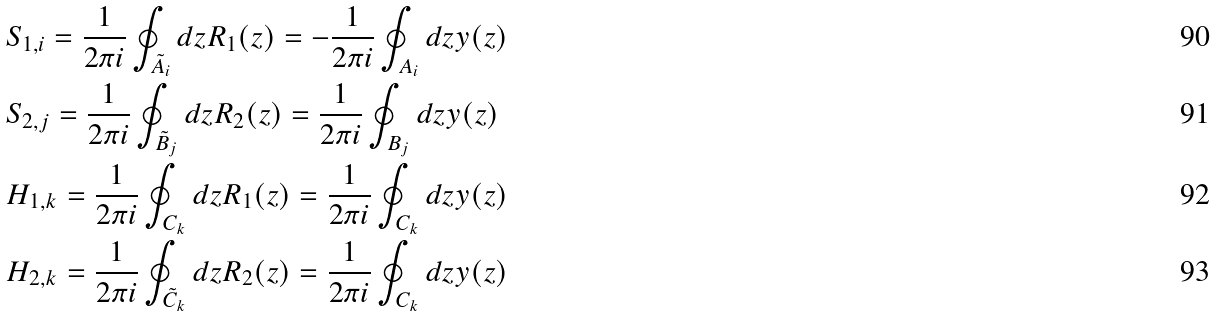<formula> <loc_0><loc_0><loc_500><loc_500>& S _ { 1 , i } = \frac { 1 } { 2 \pi i } \oint _ { \tilde { A } _ { i } } d z R _ { 1 } ( z ) = - \frac { 1 } { 2 \pi i } \oint _ { A _ { i } } d z y ( z ) \\ & S _ { 2 , j } = \frac { 1 } { 2 \pi i } \oint _ { \tilde { B } _ { j } } d z R _ { 2 } ( z ) = \frac { 1 } { 2 \pi i } \oint _ { B _ { j } } d z y ( z ) \\ & H _ { 1 , k } = \frac { 1 } { 2 \pi i } \oint _ { C _ { k } } d z R _ { 1 } ( z ) = \frac { 1 } { 2 \pi i } \oint _ { C _ { k } } d z y ( z ) \\ & H _ { 2 , k } = \frac { 1 } { 2 \pi i } \oint _ { \tilde { C } _ { k } } d z R _ { 2 } ( z ) = \frac { 1 } { 2 \pi i } \oint _ { C _ { k } } d z y ( z )</formula> 